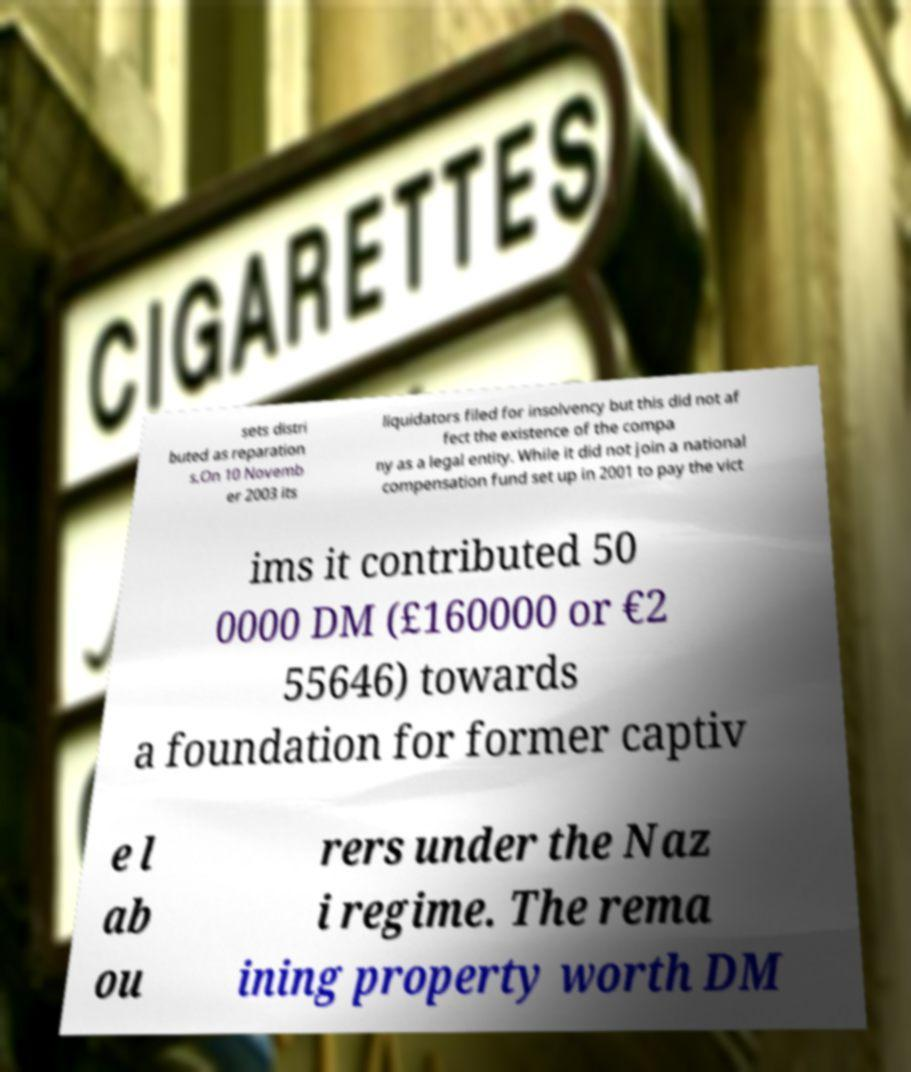Please identify and transcribe the text found in this image. sets distri buted as reparation s.On 10 Novemb er 2003 its liquidators filed for insolvency but this did not af fect the existence of the compa ny as a legal entity. While it did not join a national compensation fund set up in 2001 to pay the vict ims it contributed 50 0000 DM (£160000 or €2 55646) towards a foundation for former captiv e l ab ou rers under the Naz i regime. The rema ining property worth DM 